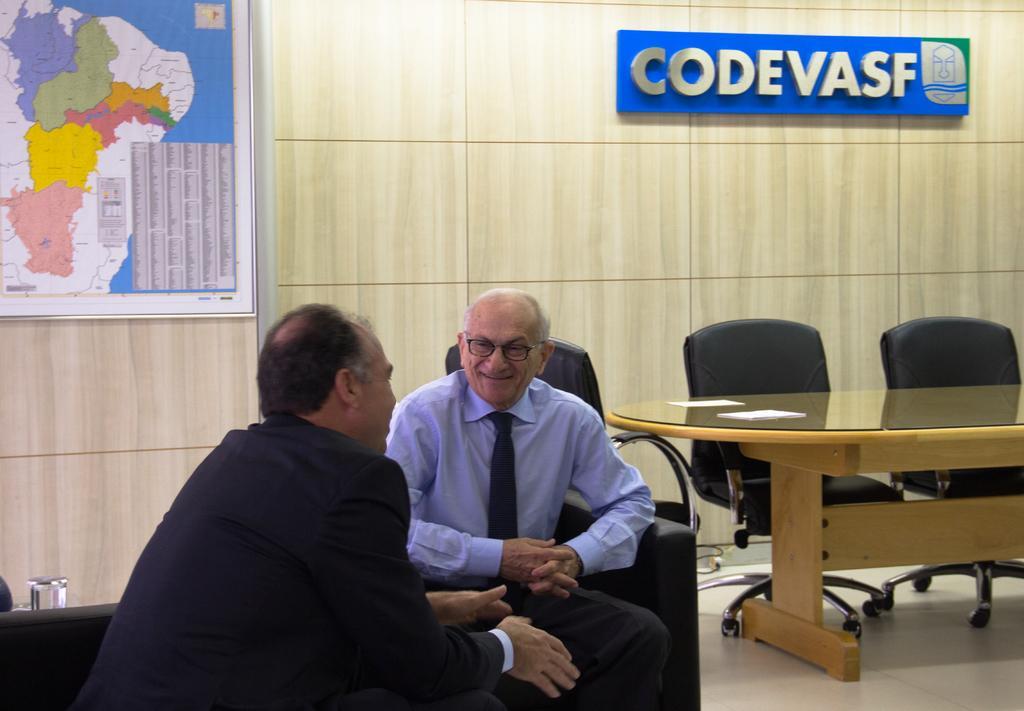How would you summarize this image in a sentence or two? In this image there are two men who are sitting in the chairs are discussing with each other. On the right side there is a table. Beside the table there are chairs. On the left side top there is a map to the wall. On the right side top there is some text which is fixed to the wall. 